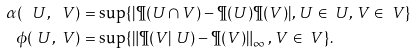<formula> <loc_0><loc_0><loc_500><loc_500>\alpha ( \ U , \ V ) & = \sup \{ | \P ( U \cap V ) - \P ( U ) \P ( V ) | , \, U \in \ U , \, V \in \ V \} \\ \phi ( \ U , \ V ) & = \sup \{ \| \P ( V | \ U ) - \P ( V ) \| _ { \infty } \, , \, V \in \ V \} .</formula> 